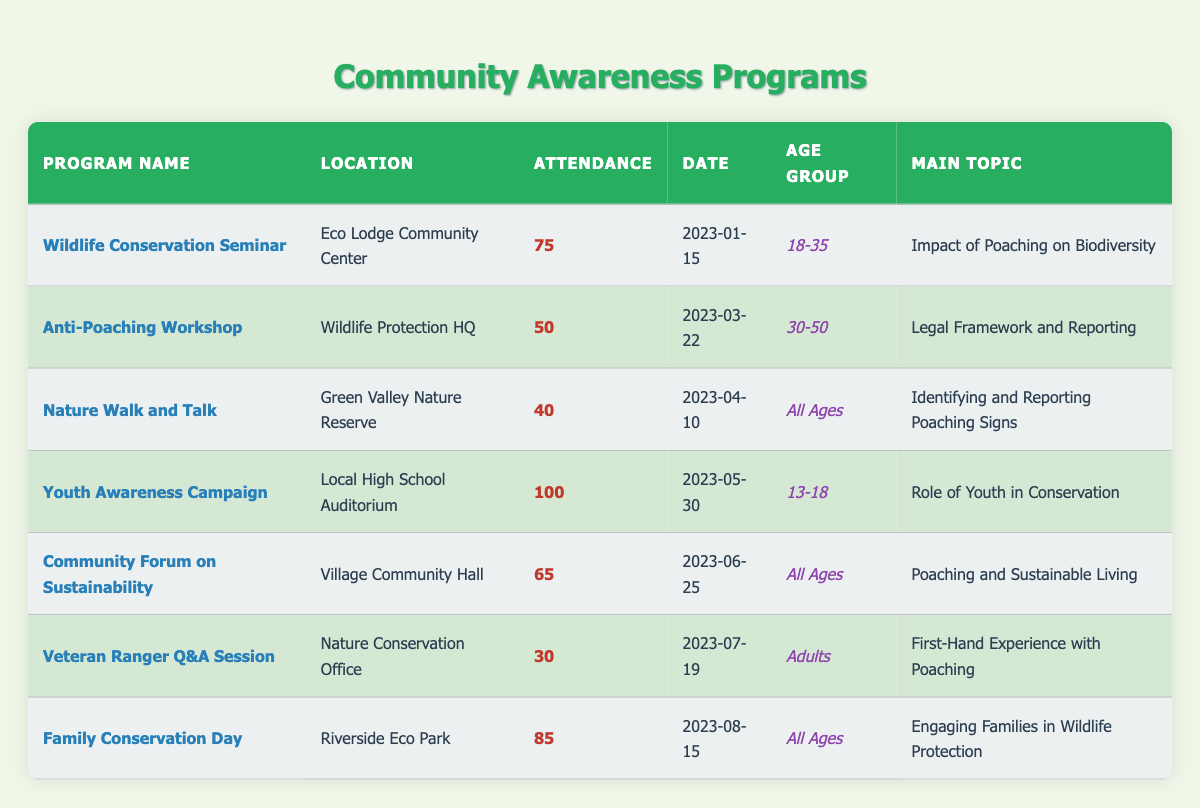What was the attendance for the Wildlife Conservation Seminar? The attendance for the Wildlife Conservation Seminar is specified directly in the table under the "Attendance" column as 75.
Answer: 75 Which program had the highest attendance? By comparing the attendance figures in the table, the program with the highest attendance is the "Youth Awareness Campaign," which had 100 attendees.
Answer: Youth Awareness Campaign How many programs had attendance rates below 60? By reviewing the attendance figures in the table, the "Anti-Poaching Workshop" (50), "Nature Walk and Talk" (40), and "Veteran Ranger Q&A Session" (30) all had attendance rates below 60. This totals to three programs.
Answer: 3 What is the average attendance across all programs? To calculate the average attendance, sum all attendance figures: 75 + 50 + 40 + 100 + 65 + 30 + 85 = 445. There are 7 programs, so divide the total by 7: 445/7 ≈ 63.57.
Answer: Approximately 64 Was the Community Forum on Sustainability attended by an age group of 30-50? The table indicates that the "Community Forum on Sustainability" was attended by "All Ages," which does not specifically include just the 30-50 age group. Therefore, it is not attended by that specific age group.
Answer: No What percentage of the programs were targeted at all ages? The programs targeting all ages are "Nature Walk and Talk," "Community Forum on Sustainability," and "Family Conservation Day," totaling 3 out of 7 programs. To find the percentage: (3/7)*100 ≈ 42.86%.
Answer: Approximately 43% Which program focused on the legal framework concerning poaching? The table specifies that the "Anti-Poaching Workshop" focused on the "Legal Framework and Reporting" in its main topic.
Answer: Anti-Poaching Workshop How does the attendance of the Family Conservation Day compare with the Wildlife Conservation Seminar? The attendance for Family Conservation Day is 85, while the Wildlife Conservation Seminar had 75. To compare, 85 is greater than 75. Therefore, Family Conservation Day had higher attendance.
Answer: Higher What was the main topic of the program held at the Wildlife Protection HQ? The program at the Wildlife Protection HQ is the "Anti-Poaching Workshop," and its main topic is "Legal Framework and Reporting," as seen in the table.
Answer: Legal Framework and Reporting 